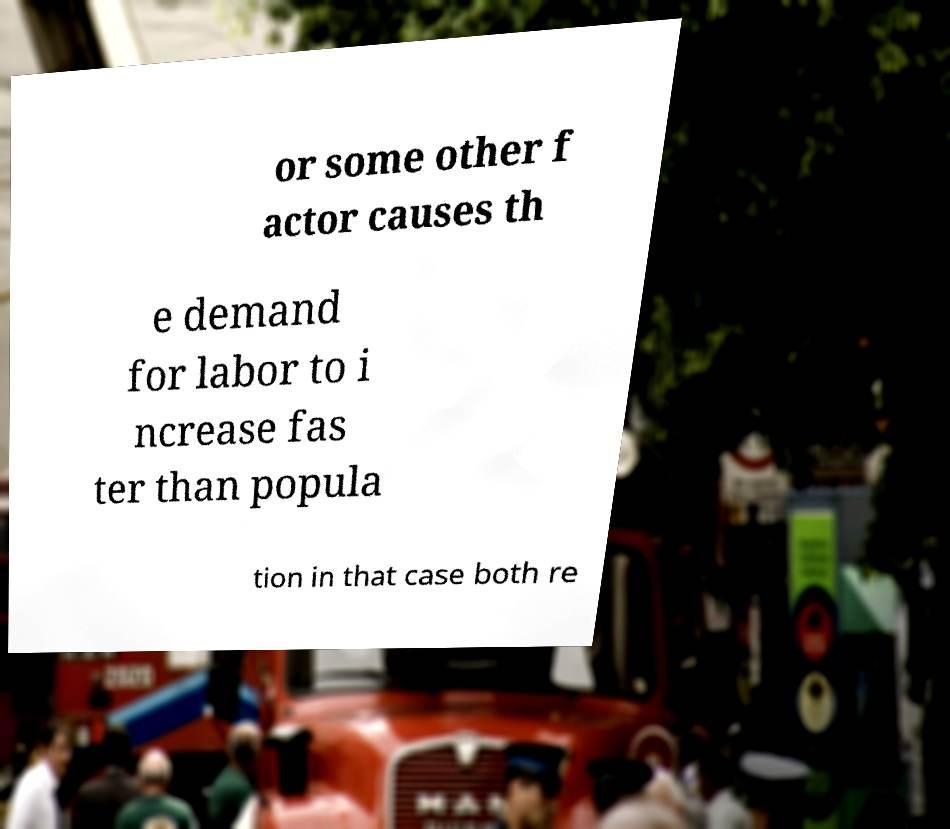For documentation purposes, I need the text within this image transcribed. Could you provide that? or some other f actor causes th e demand for labor to i ncrease fas ter than popula tion in that case both re 